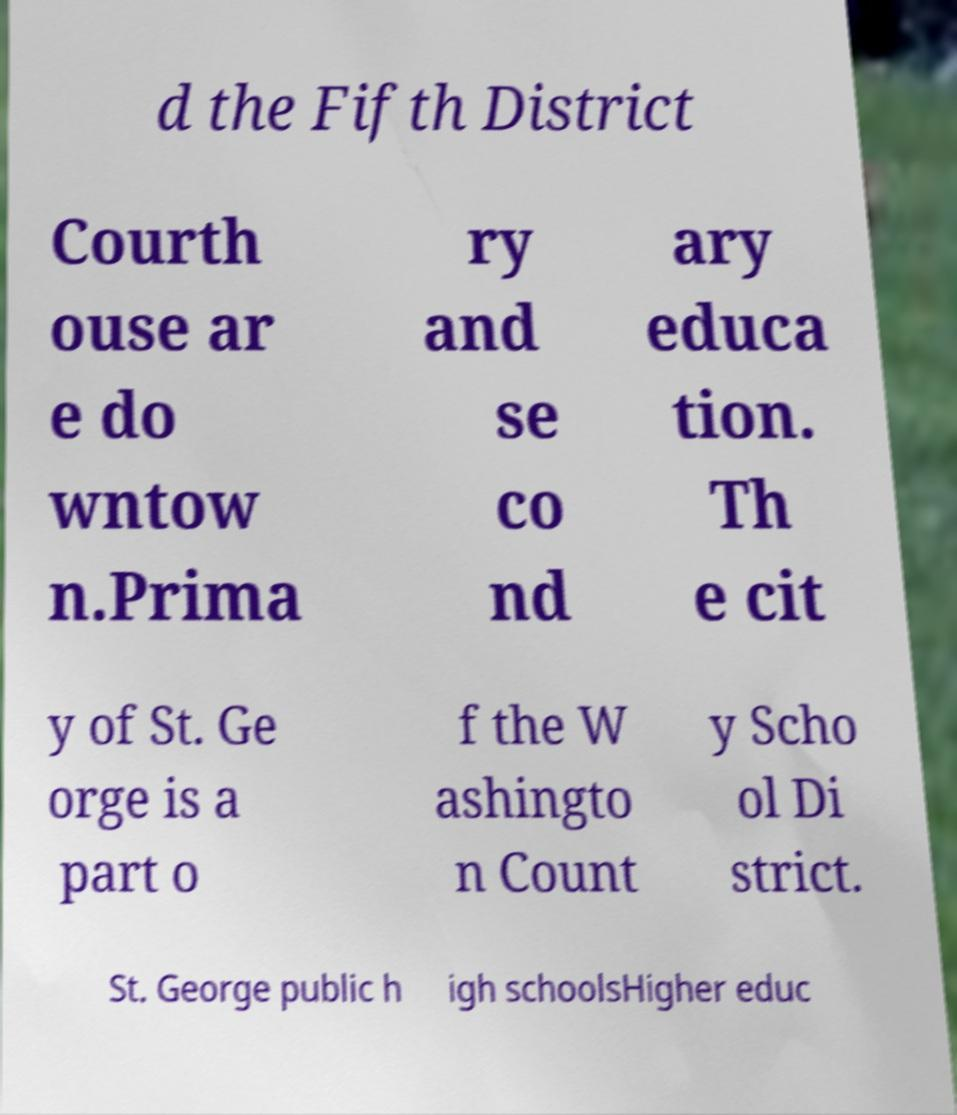Can you read and provide the text displayed in the image?This photo seems to have some interesting text. Can you extract and type it out for me? d the Fifth District Courth ouse ar e do wntow n.Prima ry and se co nd ary educa tion. Th e cit y of St. Ge orge is a part o f the W ashingto n Count y Scho ol Di strict. St. George public h igh schoolsHigher educ 